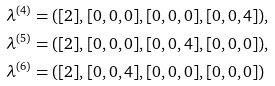Convert formula to latex. <formula><loc_0><loc_0><loc_500><loc_500>\lambda ^ { ( 4 ) } & = ( [ 2 ] , [ 0 , 0 , 0 ] , [ 0 , 0 , 0 ] , [ 0 , 0 , 4 ] ) , \\ \lambda ^ { ( 5 ) } & = ( [ 2 ] , [ 0 , 0 , 0 ] , [ 0 , 0 , 4 ] , [ 0 , 0 , 0 ] ) , \\ \lambda ^ { ( 6 ) } & = ( [ 2 ] , [ 0 , 0 , 4 ] , [ 0 , 0 , 0 ] , [ 0 , 0 , 0 ] )</formula> 